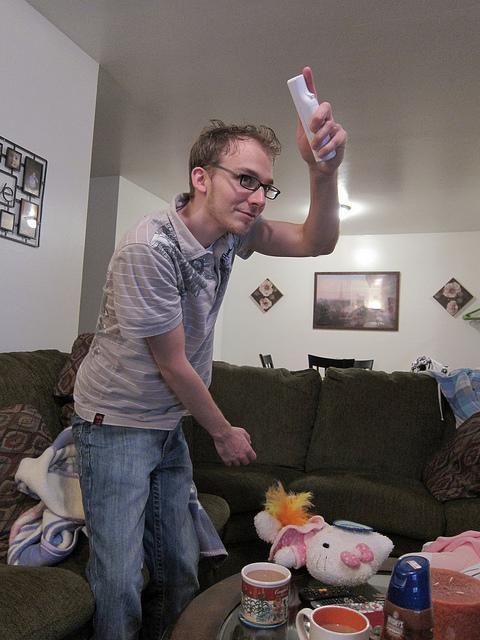What type of remote is the man holding?
Indicate the correct response by choosing from the four available options to answer the question.
Options: Xbox, playstation 5, tv, nintendo wii. Nintendo wii. 